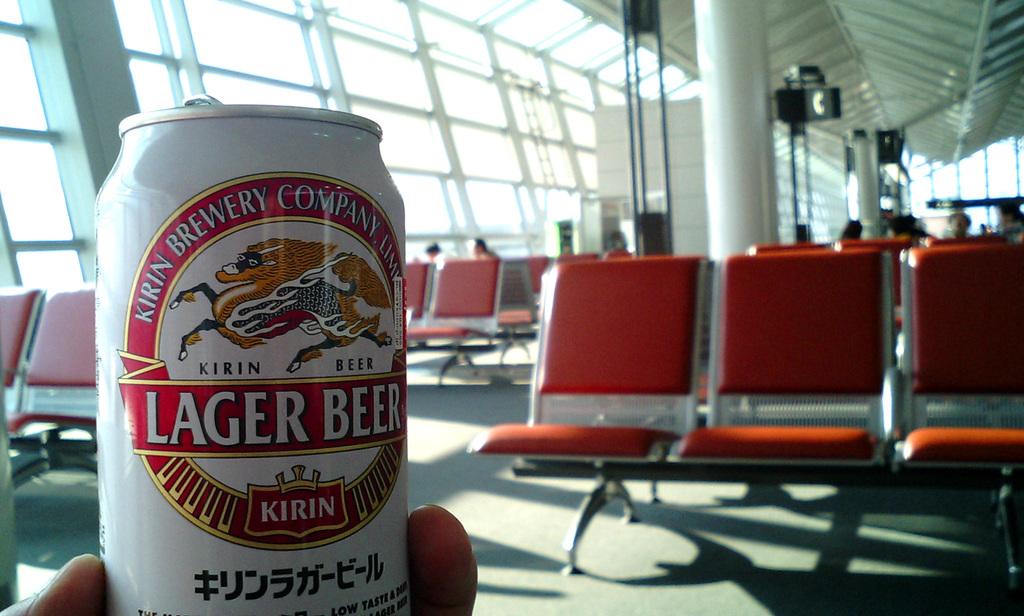What is the name of the beer?
Provide a succinct answer. Kirin. 